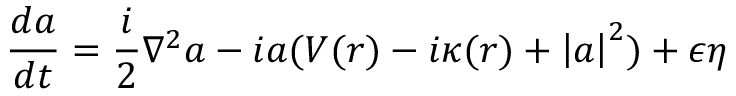<formula> <loc_0><loc_0><loc_500><loc_500>\frac { d a } { d t } = \frac { i } { 2 } \nabla ^ { 2 } a - i a ( V ( r ) - i \kappa ( r ) + \left | a \right | ^ { 2 } ) + \epsilon \eta</formula> 